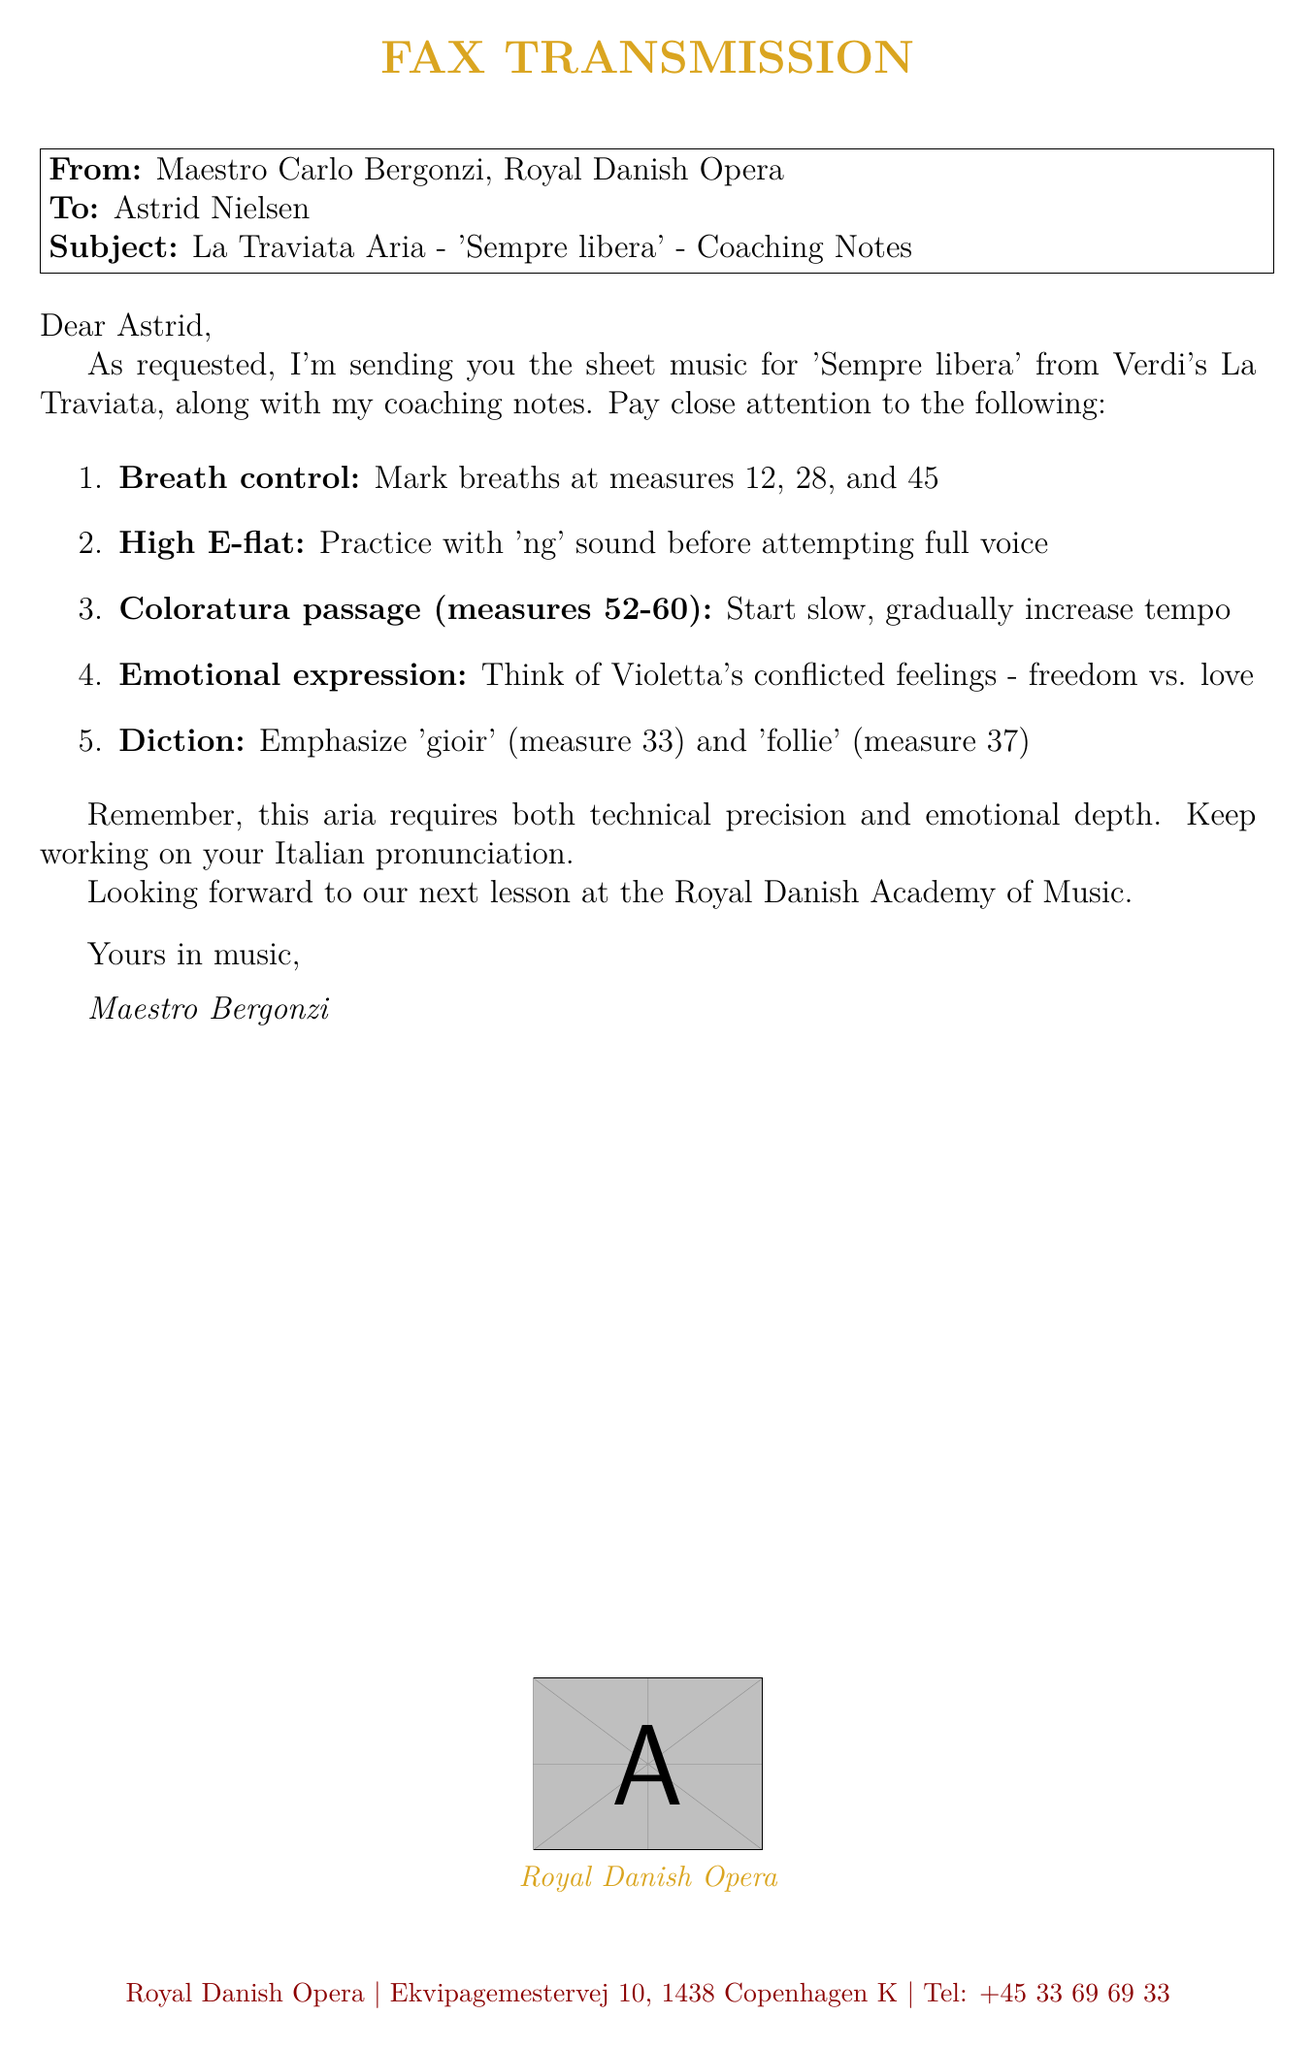What is the title of the aria? The title of the aria is mentioned in the subject line of the fax.
Answer: Sempre libera Who is the sender of the fax? The sender is identified at the beginning of the fax.
Answer: Maestro Carlo Bergonzi What is the recipient's name? The name of the recipient is listed in the address section of the fax.
Answer: Astrid Nielsen How many measures are indicated for breath control? The notes explicitly list the measures where breath control is important.
Answer: 3 What are the measures for the coloratura passage? The coloratura passage is specified in the coaching notes by measure numbers.
Answer: 52-60 What emotion should be expressed during the aria? The fax mentions a specific emotional conflict that should be conveyed while singing.
Answer: Freedom vs. love What should be emphasized in measure 33? The fax gives specific instructions regarding diction in the aria.
Answer: gioir Where is the next lesson scheduled? The last paragraph in the fax specifies the location of the next lesson.
Answer: Royal Danish Academy of Music What sound should be practiced for the high E-flat? The coaching notes indicate a specific technique for practicing the high note.
Answer: ng 